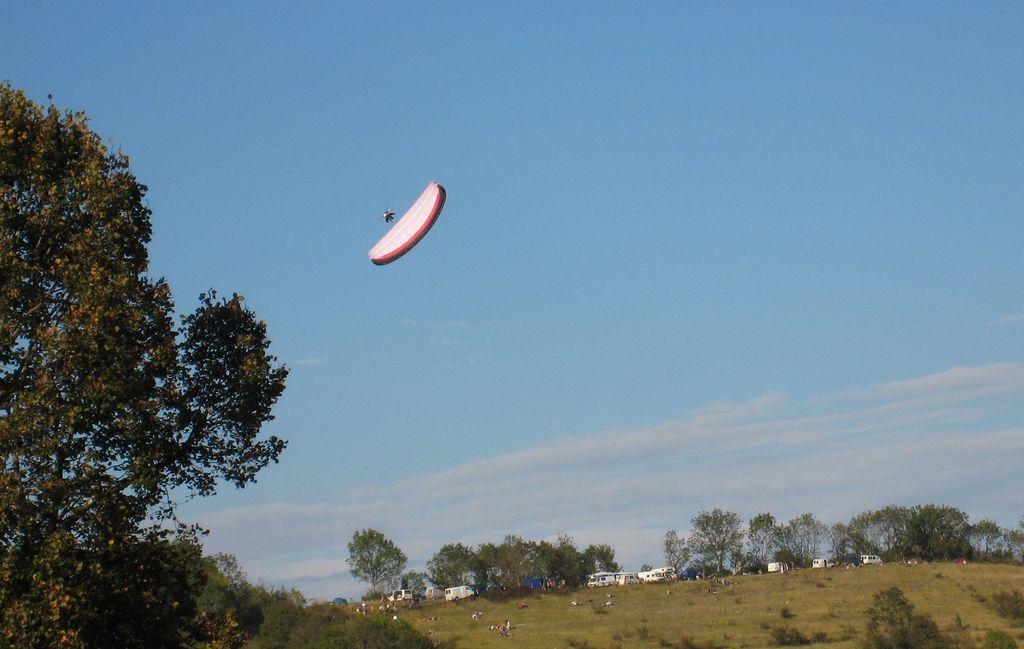In one or two sentences, can you explain what this image depicts? In this picture there are group of people and there are vehicles and trees. At the top there is sky and there are clouds and there is a person flying with the parachute. At the bottom there is grass. 